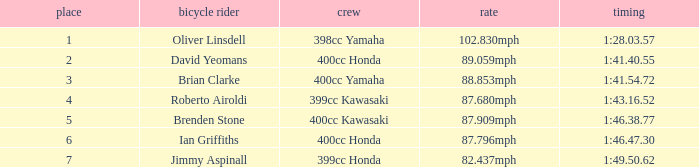Who is the rider with a 399cc Kawasaki? Roberto Airoldi. 